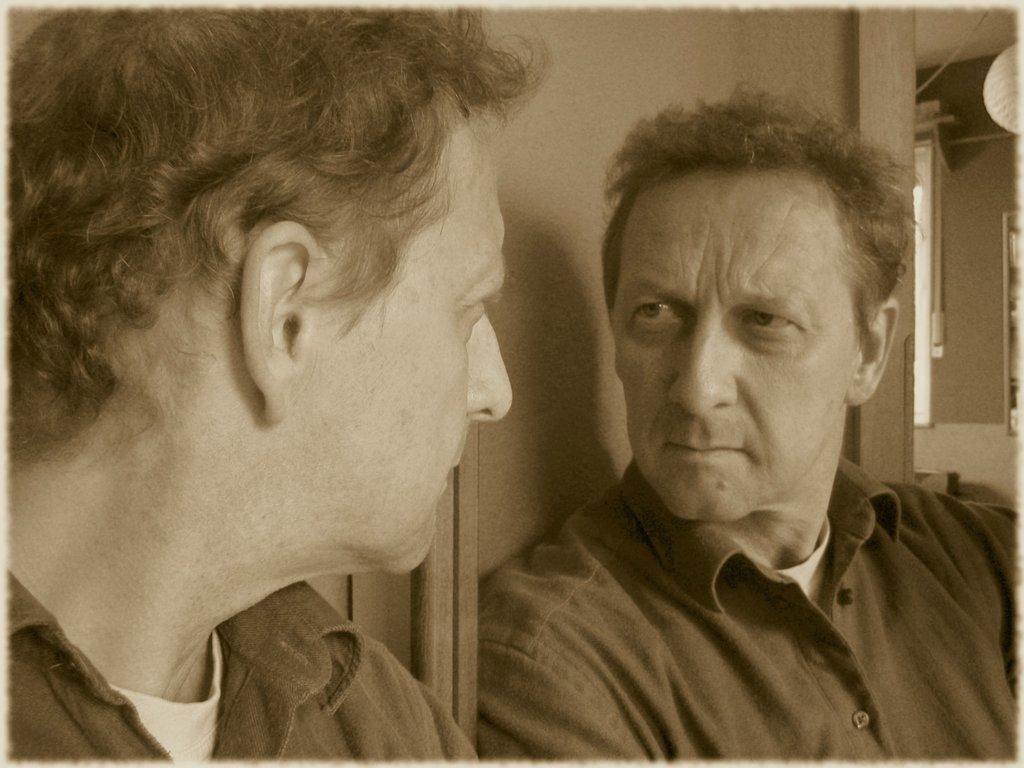How would you summarize this image in a sentence or two? In this picture we can see the man standing in front. Behind there is a glass and a reflection of the man. 